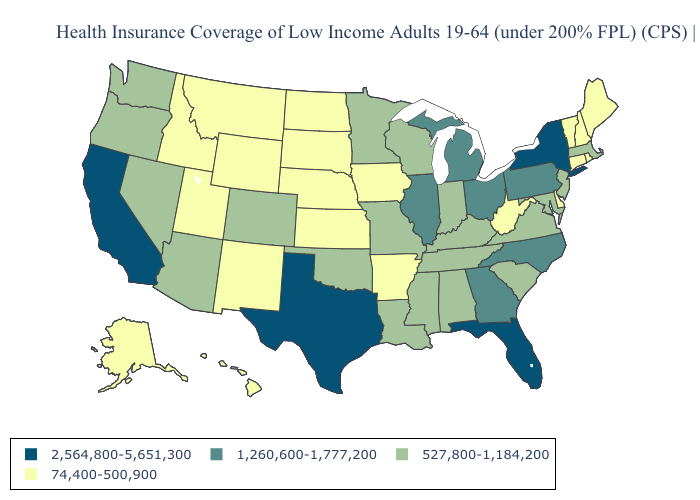Name the states that have a value in the range 2,564,800-5,651,300?
Give a very brief answer. California, Florida, New York, Texas. What is the value of Florida?
Keep it brief. 2,564,800-5,651,300. Among the states that border North Carolina , which have the lowest value?
Be succinct. South Carolina, Tennessee, Virginia. Name the states that have a value in the range 2,564,800-5,651,300?
Keep it brief. California, Florida, New York, Texas. How many symbols are there in the legend?
Give a very brief answer. 4. Among the states that border Texas , does New Mexico have the lowest value?
Quick response, please. Yes. What is the value of Nevada?
Answer briefly. 527,800-1,184,200. Does Maryland have a lower value than Kansas?
Answer briefly. No. Among the states that border Missouri , which have the highest value?
Short answer required. Illinois. What is the value of Louisiana?
Answer briefly. 527,800-1,184,200. What is the highest value in the USA?
Keep it brief. 2,564,800-5,651,300. Does Delaware have the lowest value in the South?
Keep it brief. Yes. Does Michigan have the highest value in the MidWest?
Short answer required. Yes. Is the legend a continuous bar?
Be succinct. No. What is the highest value in the USA?
Write a very short answer. 2,564,800-5,651,300. 